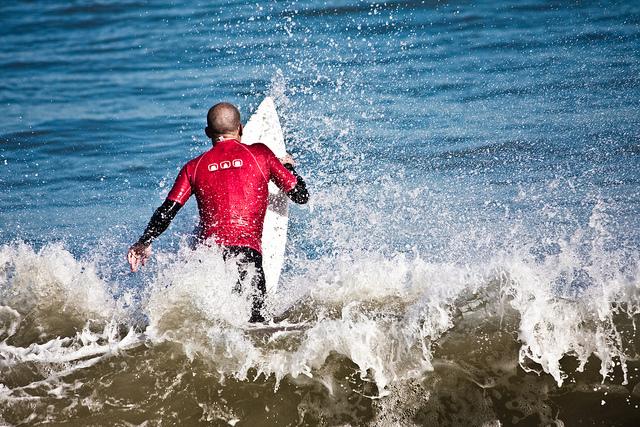What colors does the man wear?
Answer briefly. Red. What is the boy standing on?
Concise answer only. Surfboard. Was the surfer in the process of changing direction when the photo was taken?
Be succinct. No. Why might the man not want gloves on?
Keep it brief. Grab surfboard. Where is the man going?
Answer briefly. Surfing. What color is the man's wetsuit?
Answer briefly. Red. 